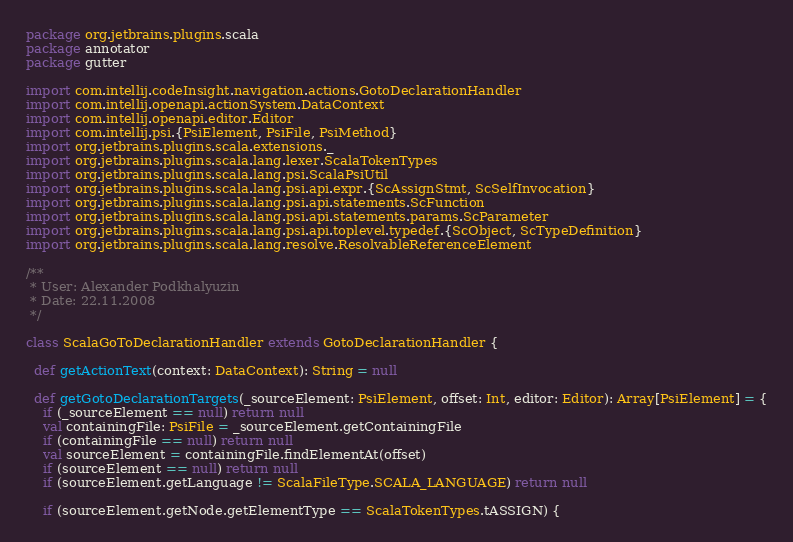<code> <loc_0><loc_0><loc_500><loc_500><_Scala_>package org.jetbrains.plugins.scala
package annotator
package gutter

import com.intellij.codeInsight.navigation.actions.GotoDeclarationHandler
import com.intellij.openapi.actionSystem.DataContext
import com.intellij.openapi.editor.Editor
import com.intellij.psi.{PsiElement, PsiFile, PsiMethod}
import org.jetbrains.plugins.scala.extensions._
import org.jetbrains.plugins.scala.lang.lexer.ScalaTokenTypes
import org.jetbrains.plugins.scala.lang.psi.ScalaPsiUtil
import org.jetbrains.plugins.scala.lang.psi.api.expr.{ScAssignStmt, ScSelfInvocation}
import org.jetbrains.plugins.scala.lang.psi.api.statements.ScFunction
import org.jetbrains.plugins.scala.lang.psi.api.statements.params.ScParameter
import org.jetbrains.plugins.scala.lang.psi.api.toplevel.typedef.{ScObject, ScTypeDefinition}
import org.jetbrains.plugins.scala.lang.resolve.ResolvableReferenceElement

/**
 * User: Alexander Podkhalyuzin
 * Date: 22.11.2008
 */

class ScalaGoToDeclarationHandler extends GotoDeclarationHandler {

  def getActionText(context: DataContext): String = null

  def getGotoDeclarationTargets(_sourceElement: PsiElement, offset: Int, editor: Editor): Array[PsiElement] = {
    if (_sourceElement == null) return null
    val containingFile: PsiFile = _sourceElement.getContainingFile
    if (containingFile == null) return null
    val sourceElement = containingFile.findElementAt(offset)
    if (sourceElement == null) return null
    if (sourceElement.getLanguage != ScalaFileType.SCALA_LANGUAGE) return null

    if (sourceElement.getNode.getElementType == ScalaTokenTypes.tASSIGN) {</code> 